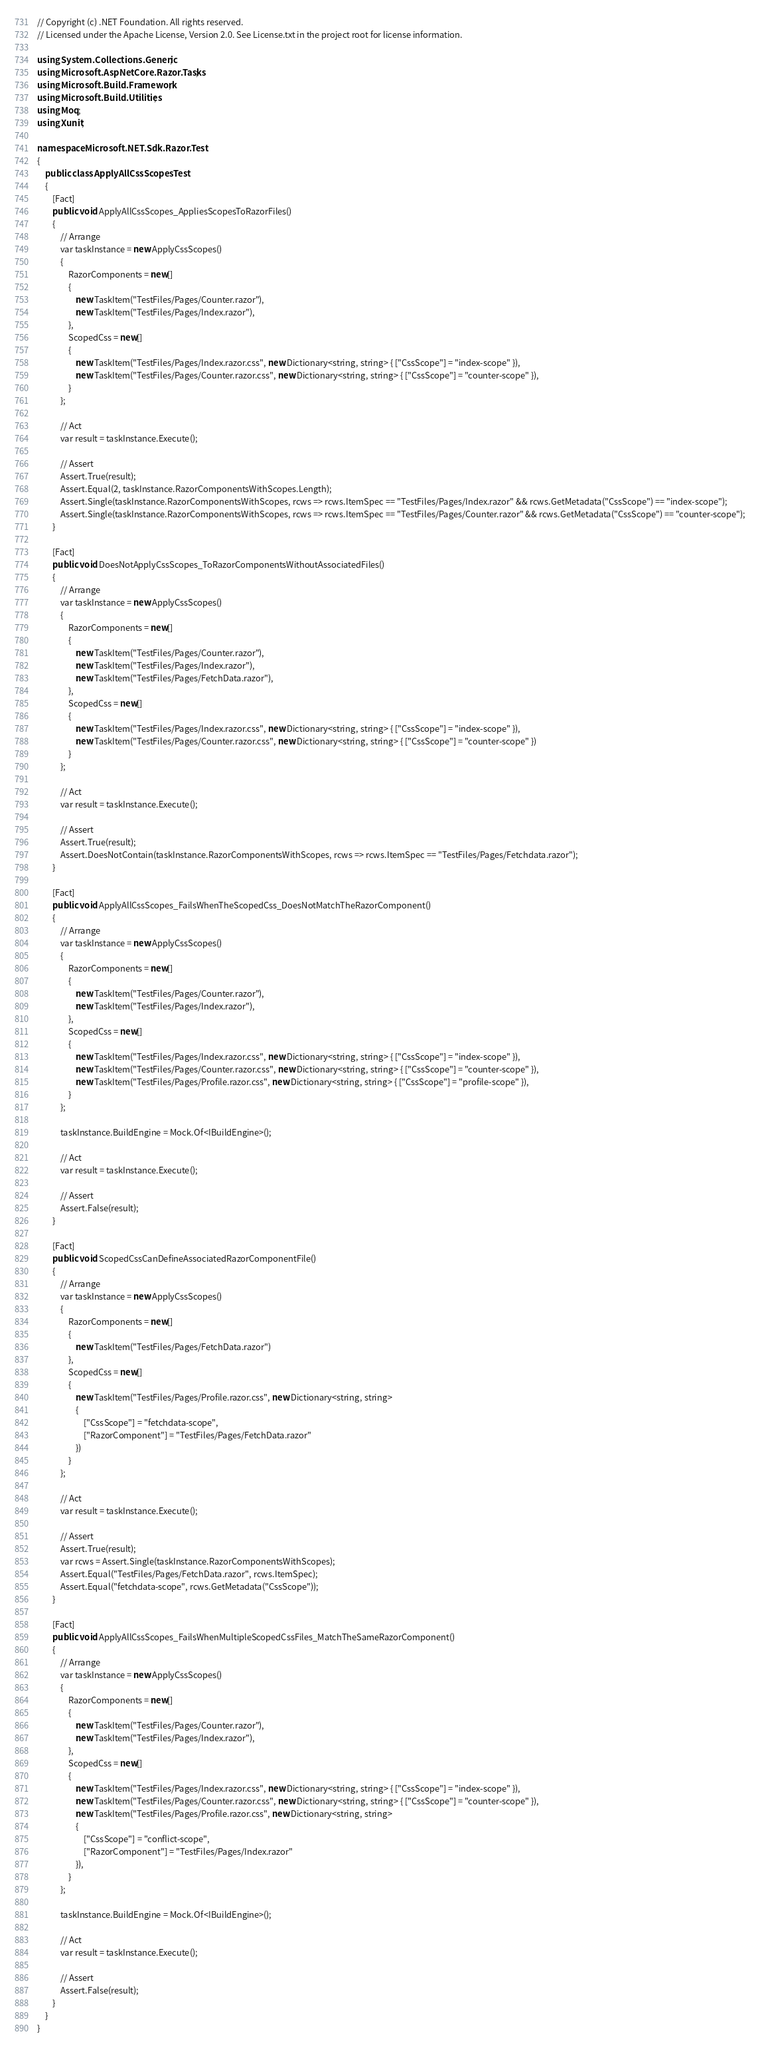Convert code to text. <code><loc_0><loc_0><loc_500><loc_500><_C#_>// Copyright (c) .NET Foundation. All rights reserved.
// Licensed under the Apache License, Version 2.0. See License.txt in the project root for license information.

using System.Collections.Generic;
using Microsoft.AspNetCore.Razor.Tasks;
using Microsoft.Build.Framework;
using Microsoft.Build.Utilities;
using Moq;
using Xunit;

namespace Microsoft.NET.Sdk.Razor.Test
{
    public class ApplyAllCssScopesTest
    {
        [Fact]
        public void ApplyAllCssScopes_AppliesScopesToRazorFiles()
        {
            // Arrange
            var taskInstance = new ApplyCssScopes()
            {
                RazorComponents = new[]
                {
                    new TaskItem("TestFiles/Pages/Counter.razor"),
                    new TaskItem("TestFiles/Pages/Index.razor"),
                },
                ScopedCss = new[]
                {
                    new TaskItem("TestFiles/Pages/Index.razor.css", new Dictionary<string, string> { ["CssScope"] = "index-scope" }),
                    new TaskItem("TestFiles/Pages/Counter.razor.css", new Dictionary<string, string> { ["CssScope"] = "counter-scope" }),
                }
            };

            // Act
            var result = taskInstance.Execute();

            // Assert
            Assert.True(result);
            Assert.Equal(2, taskInstance.RazorComponentsWithScopes.Length);
            Assert.Single(taskInstance.RazorComponentsWithScopes, rcws => rcws.ItemSpec == "TestFiles/Pages/Index.razor" && rcws.GetMetadata("CssScope") == "index-scope");
            Assert.Single(taskInstance.RazorComponentsWithScopes, rcws => rcws.ItemSpec == "TestFiles/Pages/Counter.razor" && rcws.GetMetadata("CssScope") == "counter-scope");
        }

        [Fact]
        public void DoesNotApplyCssScopes_ToRazorComponentsWithoutAssociatedFiles()
        {
            // Arrange
            var taskInstance = new ApplyCssScopes()
            {
                RazorComponents = new[]
                {
                    new TaskItem("TestFiles/Pages/Counter.razor"),
                    new TaskItem("TestFiles/Pages/Index.razor"),
                    new TaskItem("TestFiles/Pages/FetchData.razor"),
                },
                ScopedCss = new[]
                {
                    new TaskItem("TestFiles/Pages/Index.razor.css", new Dictionary<string, string> { ["CssScope"] = "index-scope" }),
                    new TaskItem("TestFiles/Pages/Counter.razor.css", new Dictionary<string, string> { ["CssScope"] = "counter-scope" })
                }
            };

            // Act
            var result = taskInstance.Execute();

            // Assert
            Assert.True(result);
            Assert.DoesNotContain(taskInstance.RazorComponentsWithScopes, rcws => rcws.ItemSpec == "TestFiles/Pages/Fetchdata.razor");
        }

        [Fact]
        public void ApplyAllCssScopes_FailsWhenTheScopedCss_DoesNotMatchTheRazorComponent()
        {
            // Arrange
            var taskInstance = new ApplyCssScopes()
            {
                RazorComponents = new[]
                {
                    new TaskItem("TestFiles/Pages/Counter.razor"),
                    new TaskItem("TestFiles/Pages/Index.razor"),
                },
                ScopedCss = new[]
                {
                    new TaskItem("TestFiles/Pages/Index.razor.css", new Dictionary<string, string> { ["CssScope"] = "index-scope" }),
                    new TaskItem("TestFiles/Pages/Counter.razor.css", new Dictionary<string, string> { ["CssScope"] = "counter-scope" }),
                    new TaskItem("TestFiles/Pages/Profile.razor.css", new Dictionary<string, string> { ["CssScope"] = "profile-scope" }),
                }
            };

            taskInstance.BuildEngine = Mock.Of<IBuildEngine>();

            // Act
            var result = taskInstance.Execute();

            // Assert
            Assert.False(result);
        }

        [Fact]
        public void ScopedCssCanDefineAssociatedRazorComponentFile()
        {
            // Arrange
            var taskInstance = new ApplyCssScopes()
            {
                RazorComponents = new[]
                {
                    new TaskItem("TestFiles/Pages/FetchData.razor")
                },
                ScopedCss = new[]
                {
                    new TaskItem("TestFiles/Pages/Profile.razor.css", new Dictionary<string, string>
                    {
                        ["CssScope"] = "fetchdata-scope",
                        ["RazorComponent"] = "TestFiles/Pages/FetchData.razor"
                    })
                }
            };

            // Act
            var result = taskInstance.Execute();

            // Assert
            Assert.True(result);
            var rcws = Assert.Single(taskInstance.RazorComponentsWithScopes);
            Assert.Equal("TestFiles/Pages/FetchData.razor", rcws.ItemSpec);
            Assert.Equal("fetchdata-scope", rcws.GetMetadata("CssScope"));
        }

        [Fact]
        public void ApplyAllCssScopes_FailsWhenMultipleScopedCssFiles_MatchTheSameRazorComponent()
        {
            // Arrange
            var taskInstance = new ApplyCssScopes()
            {
                RazorComponents = new[]
                {
                    new TaskItem("TestFiles/Pages/Counter.razor"),
                    new TaskItem("TestFiles/Pages/Index.razor"),
                },
                ScopedCss = new[]
                {
                    new TaskItem("TestFiles/Pages/Index.razor.css", new Dictionary<string, string> { ["CssScope"] = "index-scope" }),
                    new TaskItem("TestFiles/Pages/Counter.razor.css", new Dictionary<string, string> { ["CssScope"] = "counter-scope" }),
                    new TaskItem("TestFiles/Pages/Profile.razor.css", new Dictionary<string, string>
                    {
                        ["CssScope"] = "conflict-scope",
                        ["RazorComponent"] = "TestFiles/Pages/Index.razor"
                    }),
                }
            };

            taskInstance.BuildEngine = Mock.Of<IBuildEngine>();

            // Act
            var result = taskInstance.Execute();

            // Assert
            Assert.False(result);
        }
    }
}
</code> 